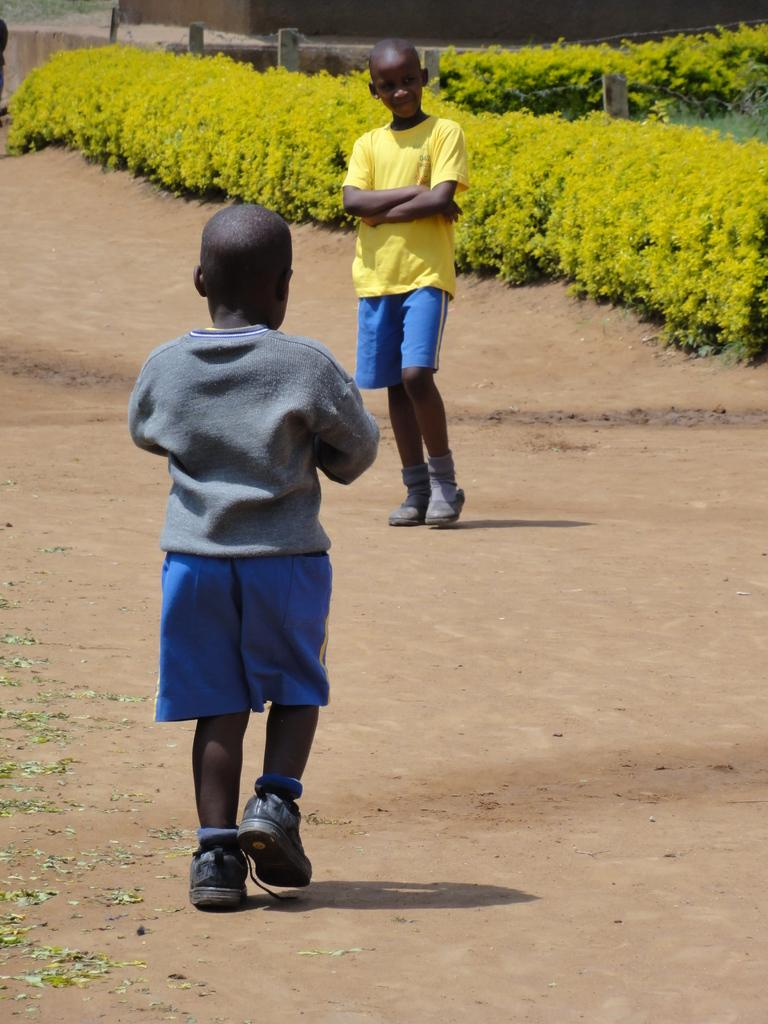How many boys are present in the image? There are two boys in the image. Where are the boys located in the image? The boys are on a path in the image. What type of vegetation can be seen in the image? There are plants in the image. What type of nail is being used by the fireman in the image? There is no fireman or nail present in the image; it features two boys on a path with plants. 